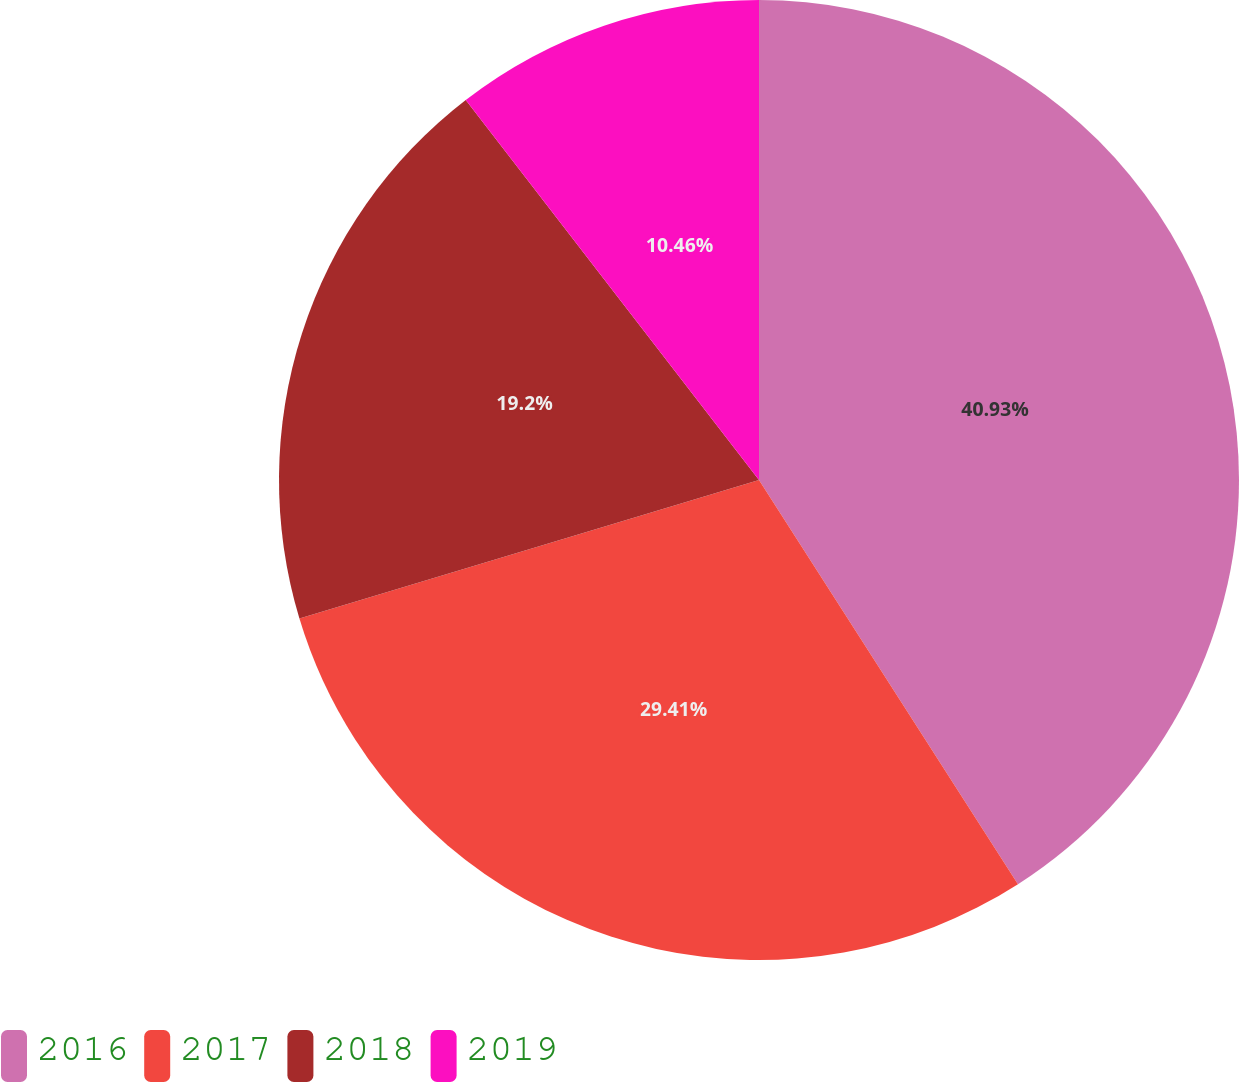Convert chart to OTSL. <chart><loc_0><loc_0><loc_500><loc_500><pie_chart><fcel>2016<fcel>2017<fcel>2018<fcel>2019<nl><fcel>40.93%<fcel>29.41%<fcel>19.2%<fcel>10.46%<nl></chart> 